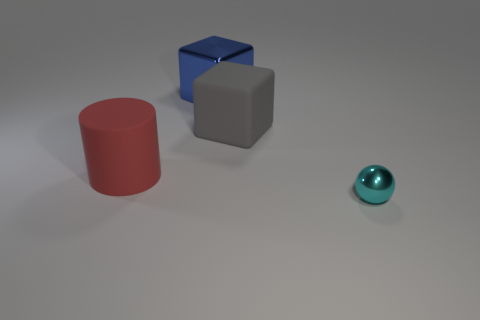Is there anything else that is the same size as the cyan metallic object?
Give a very brief answer. No. What size is the thing that is in front of the gray matte thing and on the right side of the big red cylinder?
Offer a terse response. Small. There is a thing that is on the right side of the blue metallic thing and to the left of the metallic ball; what is its color?
Provide a succinct answer. Gray. Are there fewer big cylinders in front of the big gray rubber block than shiny cubes that are to the right of the tiny cyan metallic sphere?
Ensure brevity in your answer.  No. What is the shape of the large metal thing?
Give a very brief answer. Cube. There is a big block that is the same material as the big red cylinder; what is its color?
Your answer should be compact. Gray. Is the number of big blue shiny cubes greater than the number of tiny yellow rubber blocks?
Your answer should be very brief. Yes. Is there a cyan shiny thing?
Make the answer very short. Yes. There is a large matte object that is right of the shiny thing that is on the left side of the tiny cyan metal ball; what shape is it?
Ensure brevity in your answer.  Cube. What number of objects are blocks or blocks on the left side of the big gray matte cube?
Your answer should be very brief. 2. 